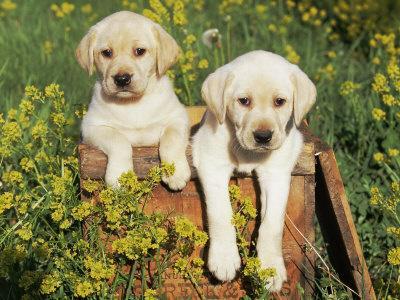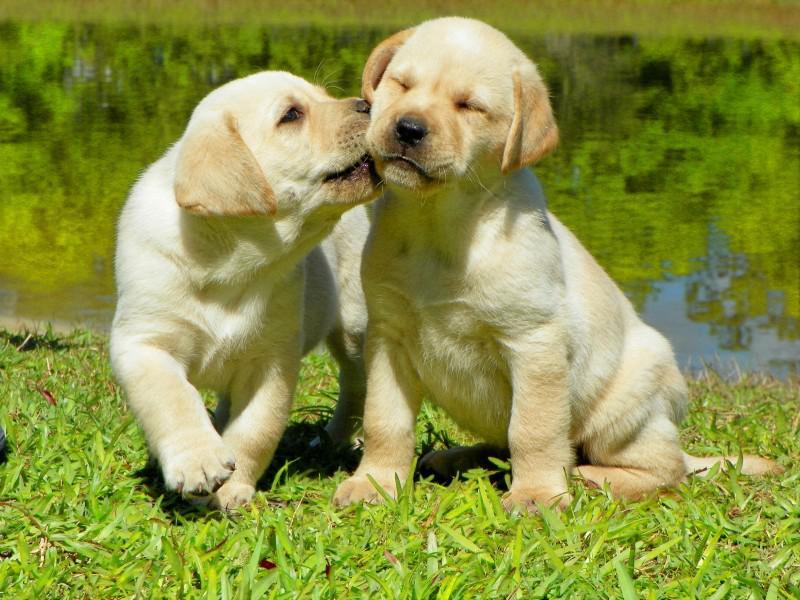The first image is the image on the left, the second image is the image on the right. Examine the images to the left and right. Is the description "One image shows side-by-side puppies posed with front paws dangling over an edge, and the other image shows one blond pup in position to lick the blond pup next to it." accurate? Answer yes or no. Yes. 